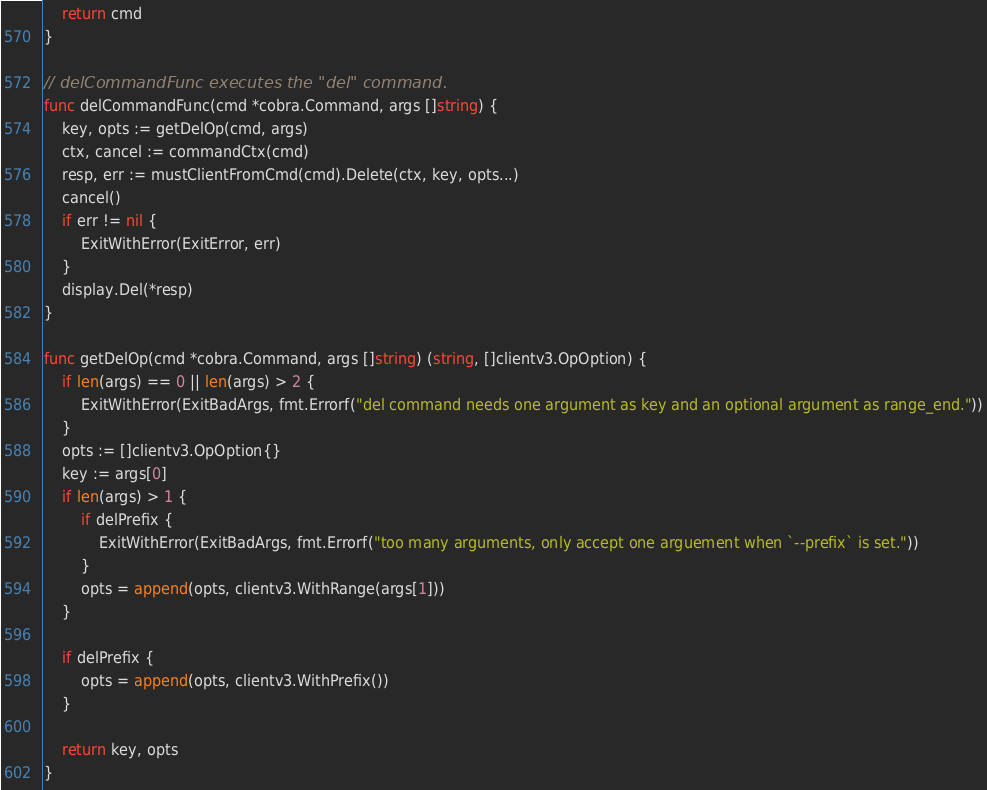Convert code to text. <code><loc_0><loc_0><loc_500><loc_500><_Go_>	return cmd
}

// delCommandFunc executes the "del" command.
func delCommandFunc(cmd *cobra.Command, args []string) {
	key, opts := getDelOp(cmd, args)
	ctx, cancel := commandCtx(cmd)
	resp, err := mustClientFromCmd(cmd).Delete(ctx, key, opts...)
	cancel()
	if err != nil {
		ExitWithError(ExitError, err)
	}
	display.Del(*resp)
}

func getDelOp(cmd *cobra.Command, args []string) (string, []clientv3.OpOption) {
	if len(args) == 0 || len(args) > 2 {
		ExitWithError(ExitBadArgs, fmt.Errorf("del command needs one argument as key and an optional argument as range_end."))
	}
	opts := []clientv3.OpOption{}
	key := args[0]
	if len(args) > 1 {
		if delPrefix {
			ExitWithError(ExitBadArgs, fmt.Errorf("too many arguments, only accept one arguement when `--prefix` is set."))
		}
		opts = append(opts, clientv3.WithRange(args[1]))
	}

	if delPrefix {
		opts = append(opts, clientv3.WithPrefix())
	}

	return key, opts
}
</code> 